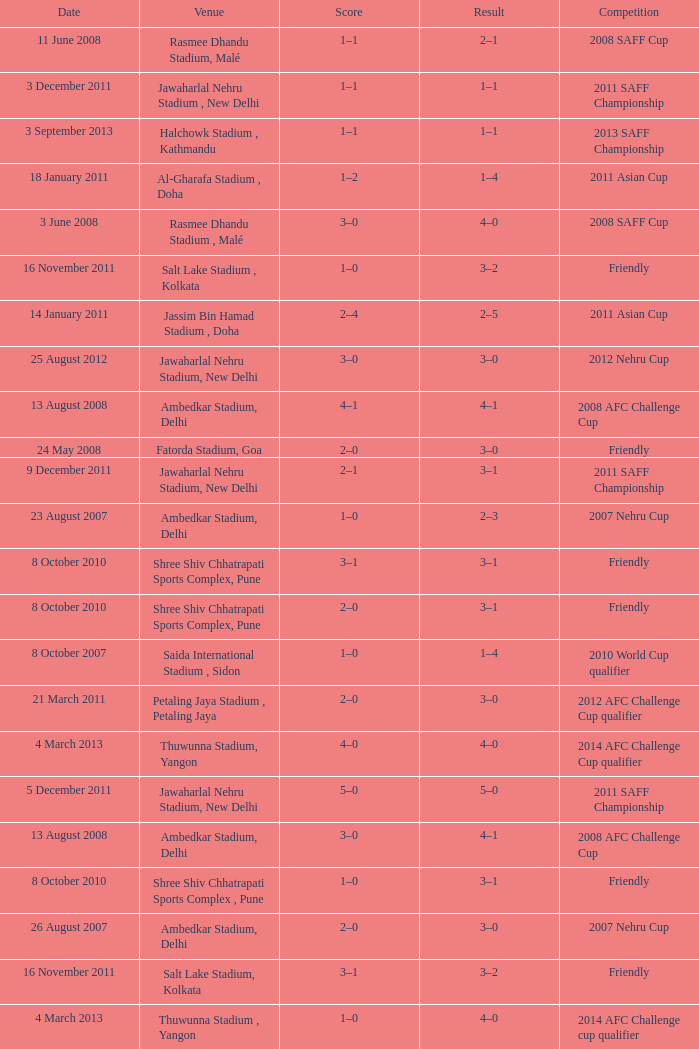Tell me the score on 22 august 2012 1–0. 